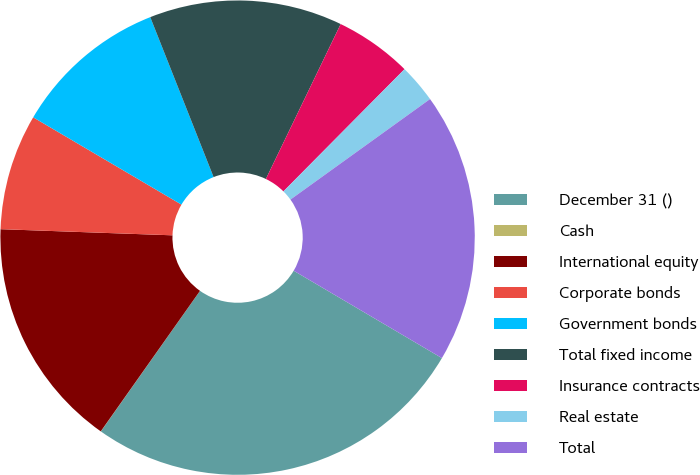Convert chart. <chart><loc_0><loc_0><loc_500><loc_500><pie_chart><fcel>December 31 ()<fcel>Cash<fcel>International equity<fcel>Corporate bonds<fcel>Government bonds<fcel>Total fixed income<fcel>Insurance contracts<fcel>Real estate<fcel>Total<nl><fcel>26.3%<fcel>0.01%<fcel>15.78%<fcel>7.9%<fcel>10.53%<fcel>13.16%<fcel>5.27%<fcel>2.64%<fcel>18.41%<nl></chart> 